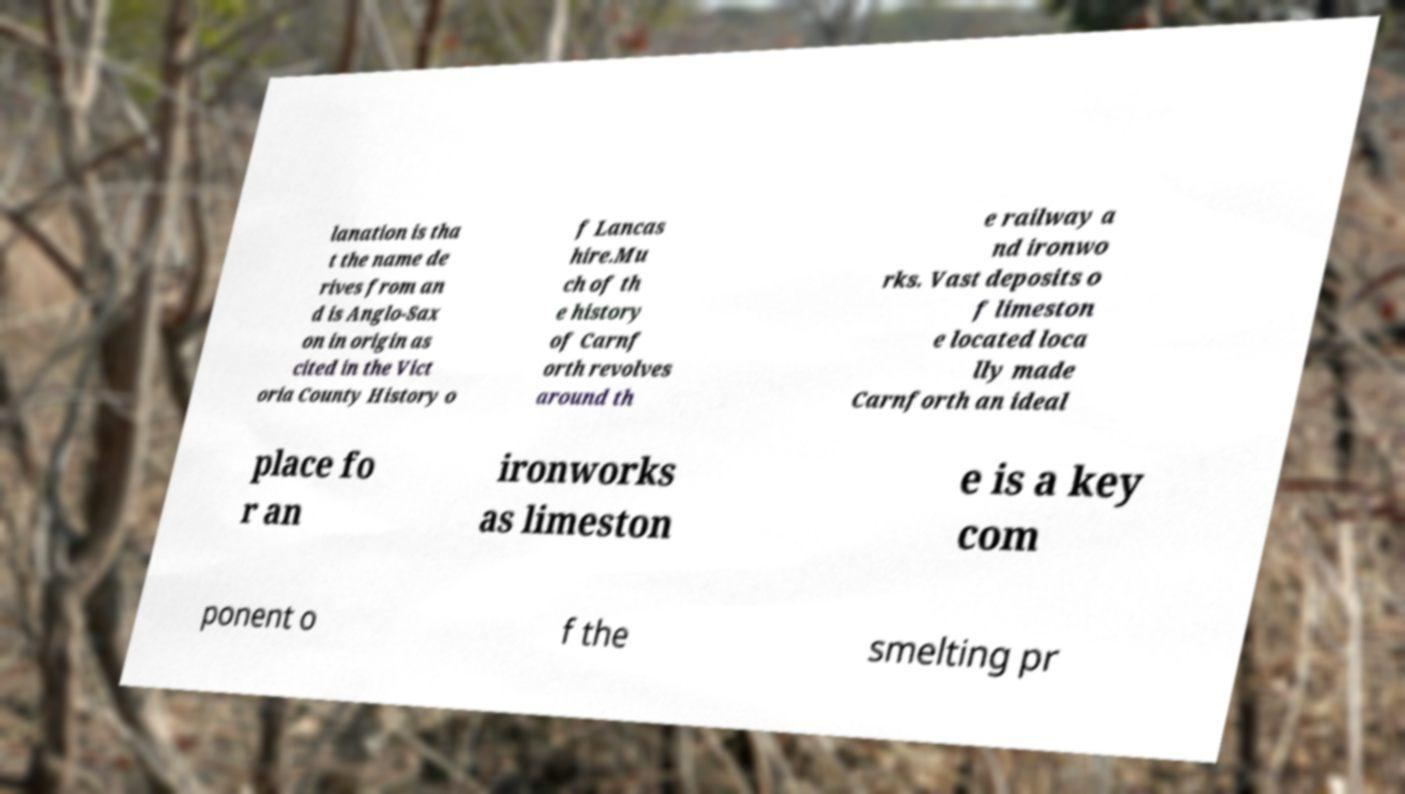What messages or text are displayed in this image? I need them in a readable, typed format. lanation is tha t the name de rives from an d is Anglo-Sax on in origin as cited in the Vict oria County History o f Lancas hire.Mu ch of th e history of Carnf orth revolves around th e railway a nd ironwo rks. Vast deposits o f limeston e located loca lly made Carnforth an ideal place fo r an ironworks as limeston e is a key com ponent o f the smelting pr 